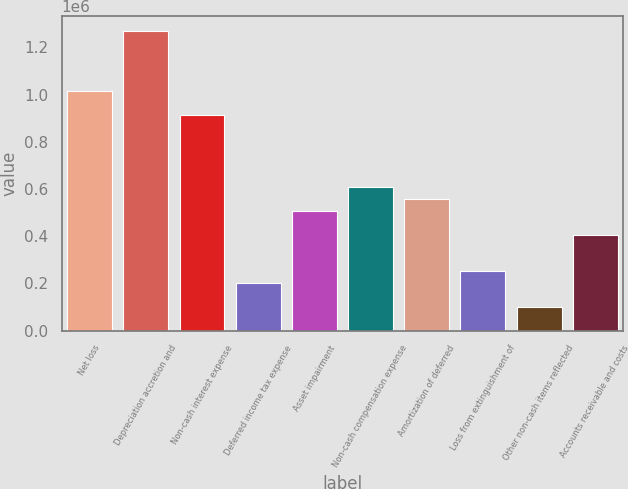Convert chart. <chart><loc_0><loc_0><loc_500><loc_500><bar_chart><fcel>Net loss<fcel>Depreciation accretion and<fcel>Non-cash interest expense<fcel>Deferred income tax expense<fcel>Asset impairment<fcel>Non-cash compensation expense<fcel>Amortization of deferred<fcel>Loss from extinguishment of<fcel>Other non-cash items reflected<fcel>Accounts receivable and costs<nl><fcel>1.01572e+06<fcel>1.26963e+06<fcel>914152<fcel>203190<fcel>507888<fcel>609454<fcel>558671<fcel>253973<fcel>101624<fcel>406322<nl></chart> 